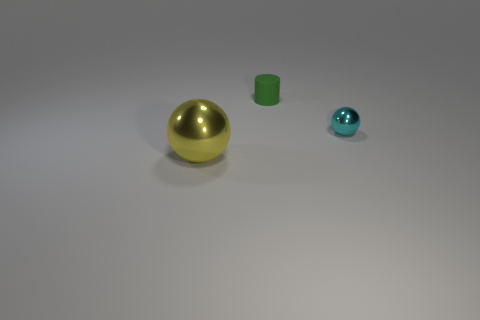Are there any other things that are the same size as the yellow metallic sphere?
Give a very brief answer. No. Are there any other things that have the same material as the small cylinder?
Your answer should be very brief. No. What color is the other metallic object that is the same shape as the small cyan metallic object?
Give a very brief answer. Yellow. There is a ball that is to the right of the big ball; what number of small cyan spheres are behind it?
Your response must be concise. 0. What number of blocks are small yellow things or large yellow metallic things?
Give a very brief answer. 0. Are any green cylinders visible?
Your answer should be very brief. Yes. There is another metallic object that is the same shape as the large yellow thing; what is its size?
Provide a short and direct response. Small. What shape is the green thing behind the sphere on the left side of the small shiny ball?
Give a very brief answer. Cylinder. How many cyan things are tiny matte cylinders or metal spheres?
Offer a terse response. 1. The large sphere is what color?
Provide a succinct answer. Yellow. 